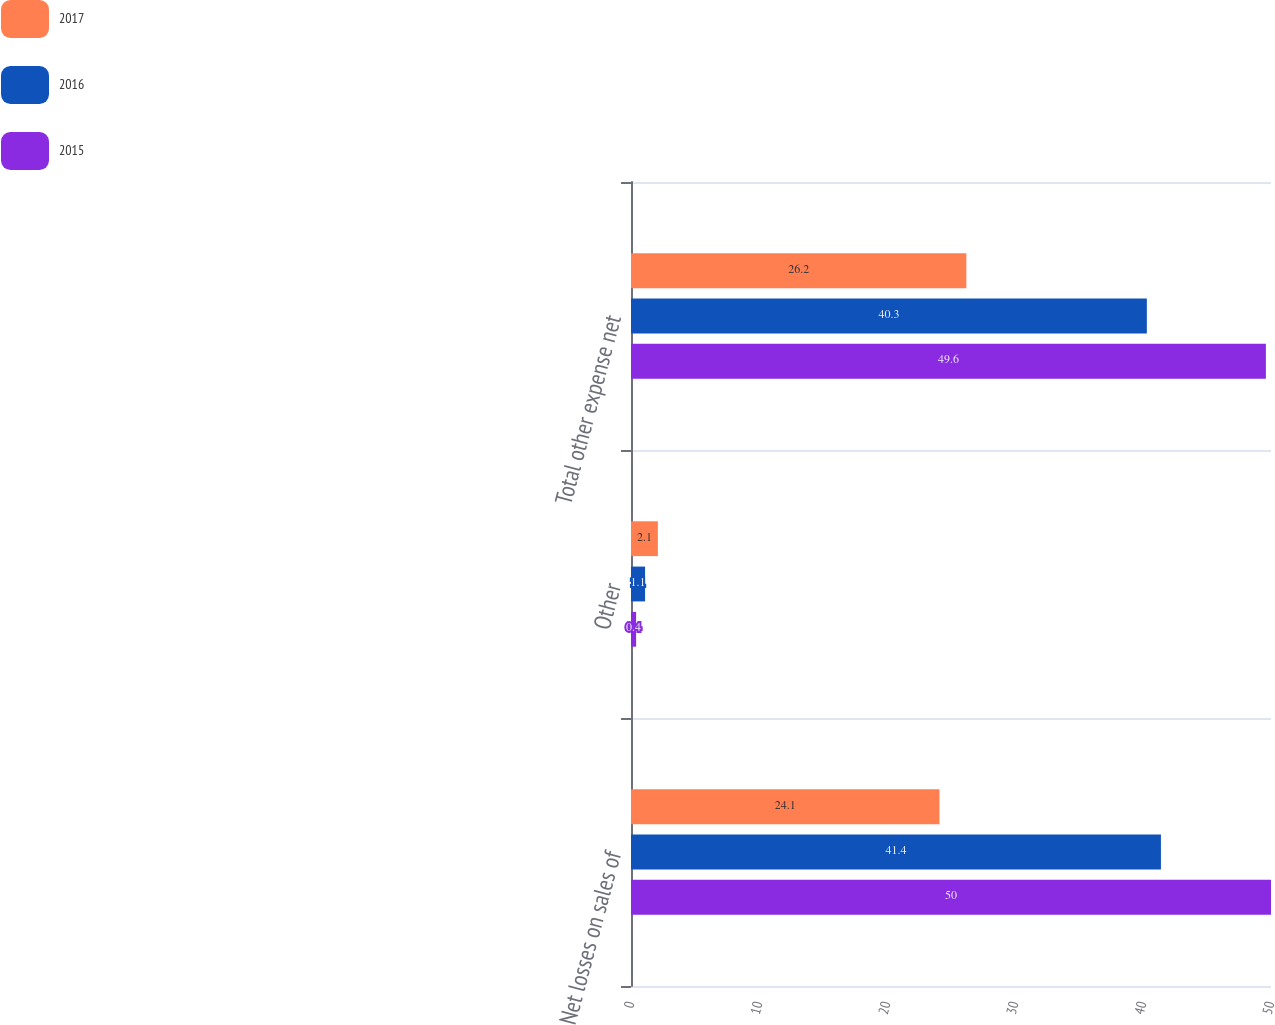Convert chart. <chart><loc_0><loc_0><loc_500><loc_500><stacked_bar_chart><ecel><fcel>Net losses on sales of<fcel>Other<fcel>Total other expense net<nl><fcel>2017<fcel>24.1<fcel>2.1<fcel>26.2<nl><fcel>2016<fcel>41.4<fcel>1.1<fcel>40.3<nl><fcel>2015<fcel>50<fcel>0.4<fcel>49.6<nl></chart> 